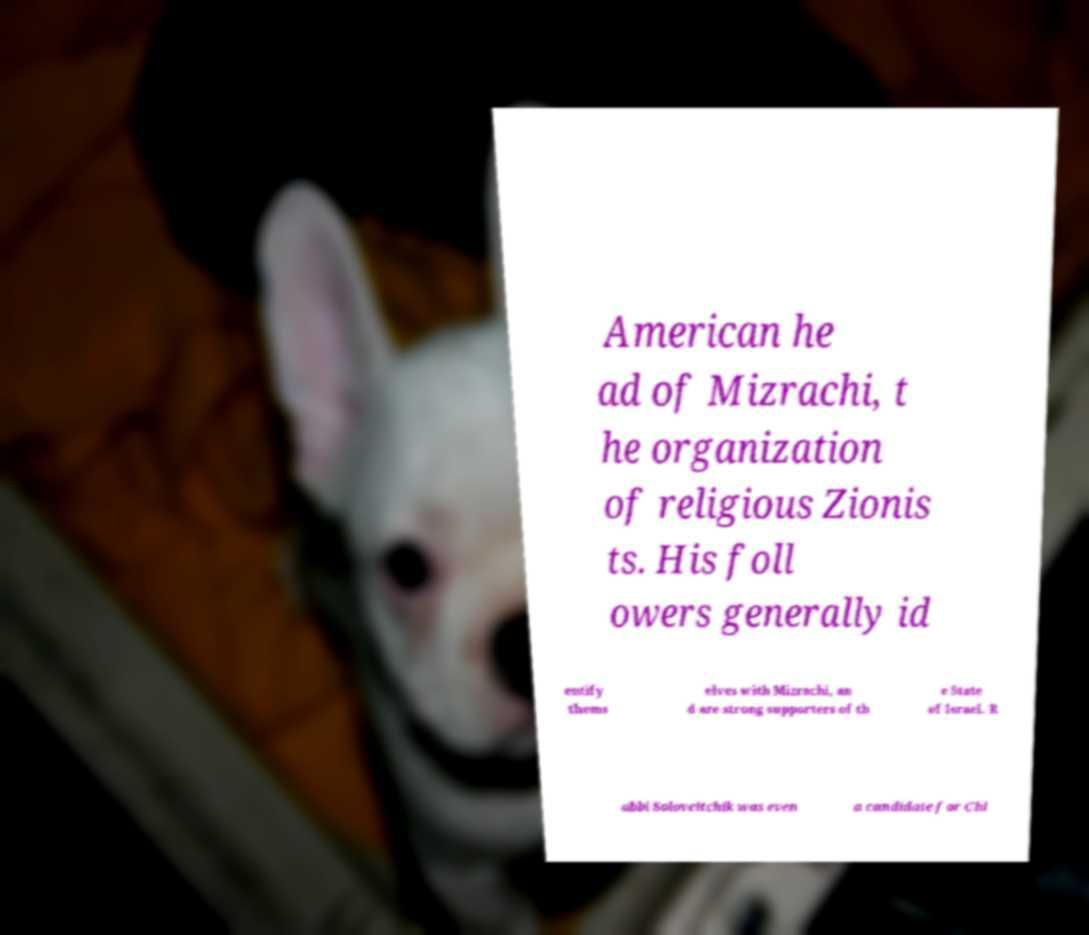I need the written content from this picture converted into text. Can you do that? American he ad of Mizrachi, t he organization of religious Zionis ts. His foll owers generally id entify thems elves with Mizrachi, an d are strong supporters of th e State of Israel. R abbi Soloveitchik was even a candidate for Chi 